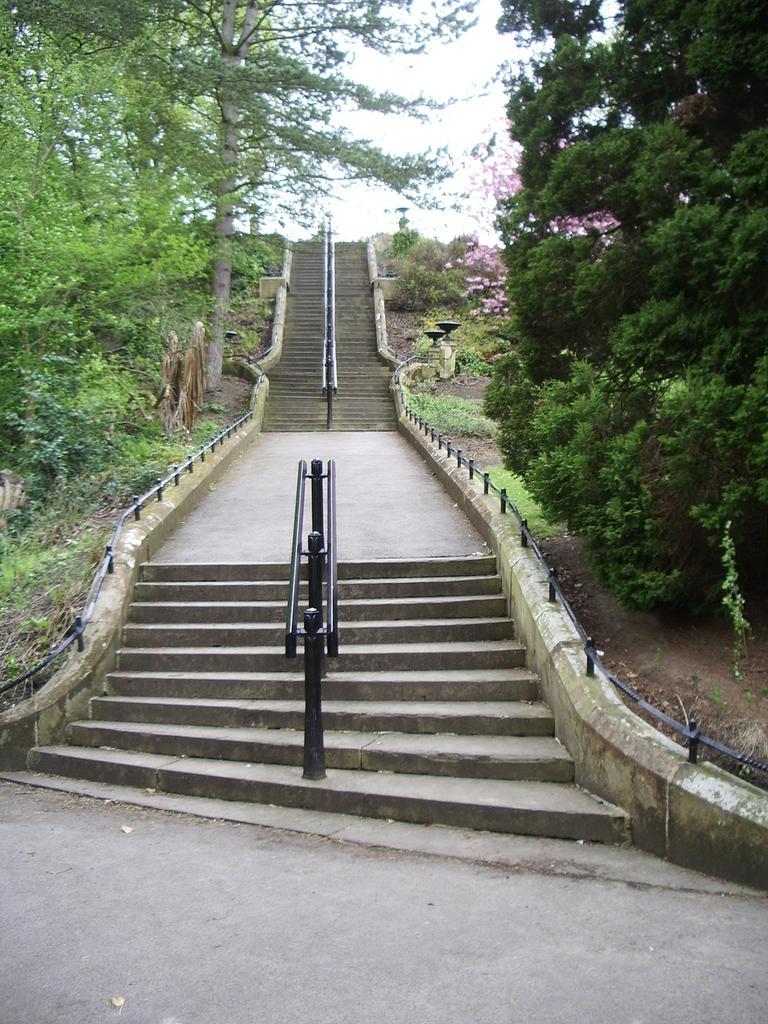Could you give a brief overview of what you see in this image? In this picture I can see stairs and i can see a metal roads to hold, in the middle of the stairs and I can see trees and a cloudy sky. 